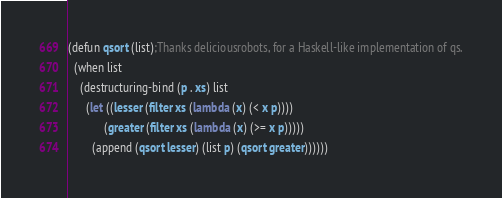Convert code to text. <code><loc_0><loc_0><loc_500><loc_500><_Lisp_>(defun qsort (list);Thanks deliciousrobots, for a Haskell-like implementation of qs.
  (when list
    (destructuring-bind (p . xs) list
      (let ((lesser (filter xs (lambda (x) (< x p))))
            (greater (filter xs (lambda (x) (>= x p)))))
        (append (qsort lesser) (list p) (qsort greater))))))
</code> 